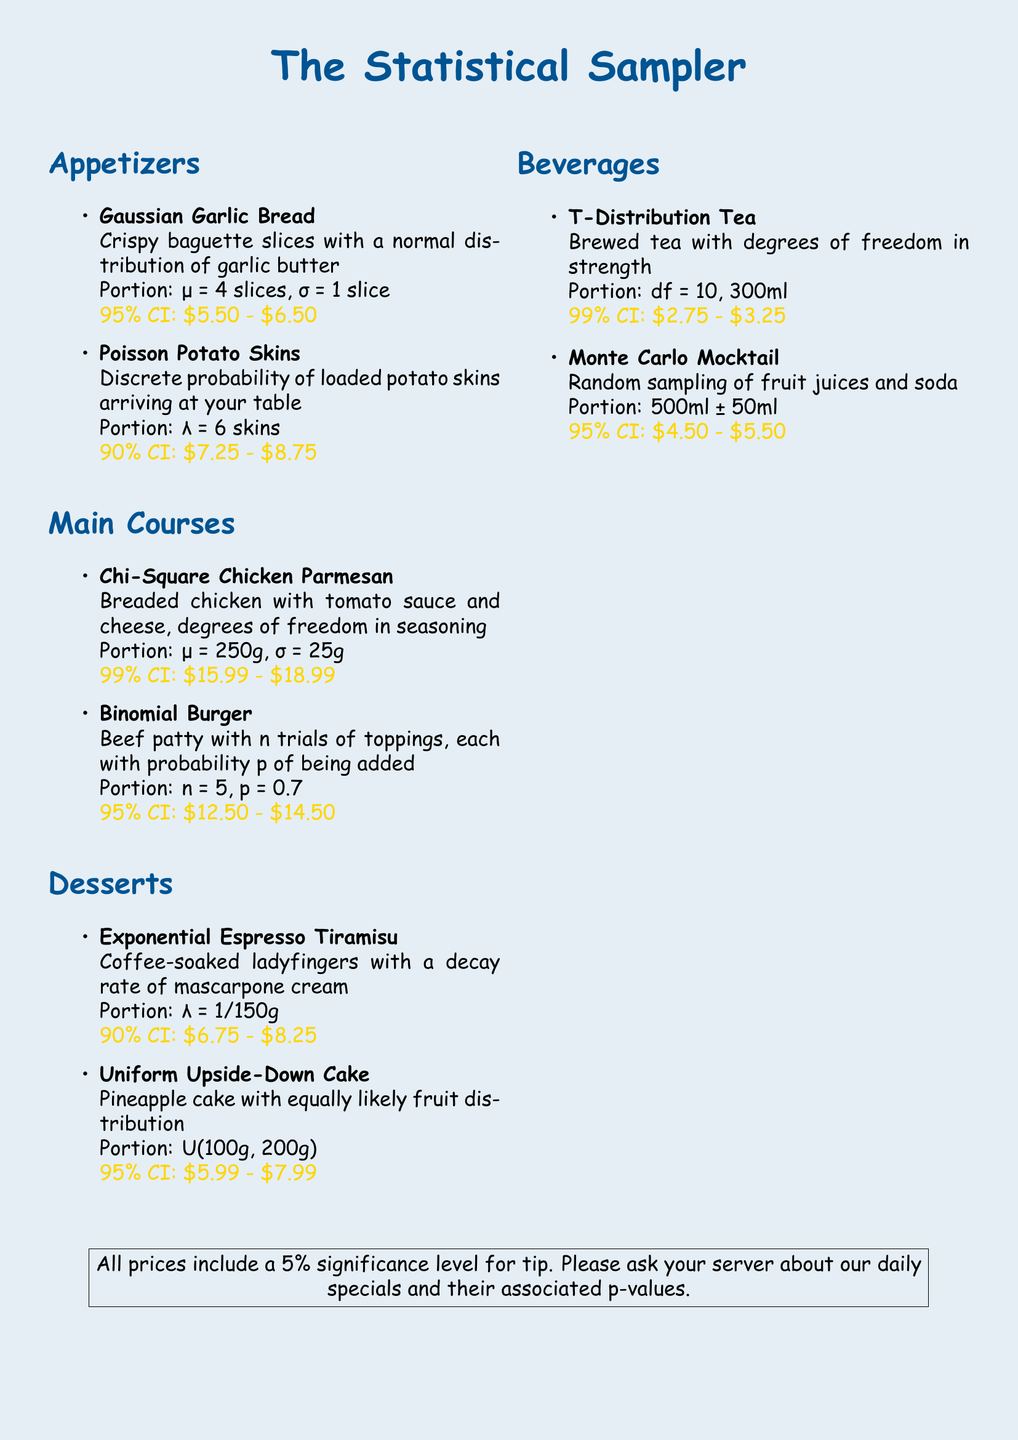What is the title of the menu? The title of the menu is prominently displayed at the top of the document as "The Statistical Sampler."
Answer: The Statistical Sampler How many slices are included in the Gaussian Garlic Bread portion? The portion size for Gaussian Garlic Bread is specified with a mean (μ) of 4 slices.
Answer: 4 slices What is the price range of the Chi-Square Chicken Parmesan? The price range is indicated with a 99% confidence interval of $15.99 to $18.99.
Answer: $15.99 - $18.99 What distribution is used to describe the Uniform Upside-Down Cake? The document specifies that the distribution of the cake is uniformly distributed between two values.
Answer: U(100g, 200g) How many potato skins are expected in the Poisson Potato Skins dish? The portion for Poisson Potato Skins is defined as lambda (λ) equal to 6 skins.
Answer: 6 skins What is the portion size for the Exponential Espresso Tiramisu? The portion size for this dessert is given with a decay rate defined as lambda (λ).
Answer: λ = 1/150g What beverage has a 99% confidence interval price range of $2.75 to $3.25? The menu indicates this price range for T-Distribution Tea.
Answer: T-Distribution Tea What is the portion size for the Monte Carlo Mocktail? The portion size is described as 500ml with an uncertainty of ±50ml.
Answer: 500ml ± 50ml What is suggested to be included in the prices? The document mentions that all prices include a 5% significance level for tip.
Answer: 5% significance level for tip 